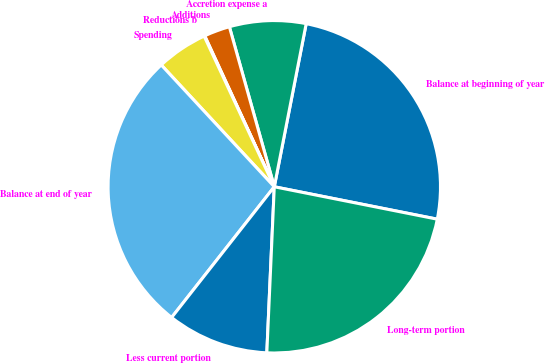<chart> <loc_0><loc_0><loc_500><loc_500><pie_chart><fcel>Balance at beginning of year<fcel>Accretion expense a<fcel>Additions<fcel>Reductions b<fcel>Spending<fcel>Balance at end of year<fcel>Less current portion<fcel>Long-term portion<nl><fcel>25.05%<fcel>7.43%<fcel>2.52%<fcel>0.06%<fcel>4.97%<fcel>27.5%<fcel>9.88%<fcel>22.59%<nl></chart> 